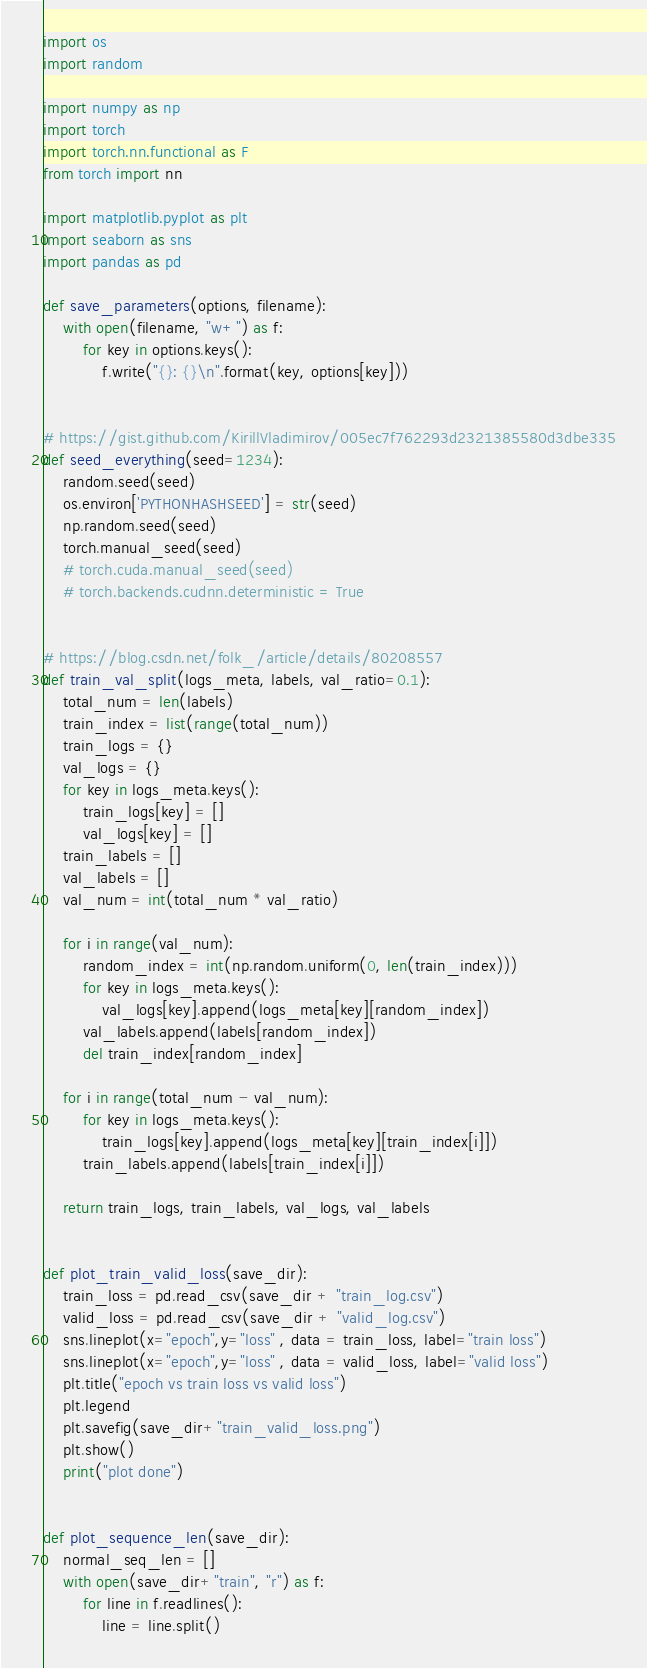<code> <loc_0><loc_0><loc_500><loc_500><_Python_>import os
import random

import numpy as np
import torch
import torch.nn.functional as F
from torch import nn

import matplotlib.pyplot as plt
import seaborn as sns
import pandas as pd

def save_parameters(options, filename):
    with open(filename, "w+") as f:
        for key in options.keys():
            f.write("{}: {}\n".format(key, options[key]))


# https://gist.github.com/KirillVladimirov/005ec7f762293d2321385580d3dbe335
def seed_everything(seed=1234):
    random.seed(seed)
    os.environ['PYTHONHASHSEED'] = str(seed)
    np.random.seed(seed)
    torch.manual_seed(seed)
    # torch.cuda.manual_seed(seed)
    # torch.backends.cudnn.deterministic = True


# https://blog.csdn.net/folk_/article/details/80208557
def train_val_split(logs_meta, labels, val_ratio=0.1):
    total_num = len(labels)
    train_index = list(range(total_num))
    train_logs = {}
    val_logs = {}
    for key in logs_meta.keys():
        train_logs[key] = []
        val_logs[key] = []
    train_labels = []
    val_labels = []
    val_num = int(total_num * val_ratio)

    for i in range(val_num):
        random_index = int(np.random.uniform(0, len(train_index)))
        for key in logs_meta.keys():
            val_logs[key].append(logs_meta[key][random_index])
        val_labels.append(labels[random_index])
        del train_index[random_index]

    for i in range(total_num - val_num):
        for key in logs_meta.keys():
            train_logs[key].append(logs_meta[key][train_index[i]])
        train_labels.append(labels[train_index[i]])

    return train_logs, train_labels, val_logs, val_labels


def plot_train_valid_loss(save_dir):
    train_loss = pd.read_csv(save_dir + "train_log.csv")
    valid_loss = pd.read_csv(save_dir + "valid_log.csv")
    sns.lineplot(x="epoch",y="loss" , data = train_loss, label="train loss")
    sns.lineplot(x="epoch",y="loss" , data = valid_loss, label="valid loss")
    plt.title("epoch vs train loss vs valid loss")
    plt.legend
    plt.savefig(save_dir+"train_valid_loss.png")
    plt.show()
    print("plot done")


def plot_sequence_len(save_dir):
    normal_seq_len = []
    with open(save_dir+"train", "r") as f:
        for line in f.readlines():
            line = line.split()</code> 